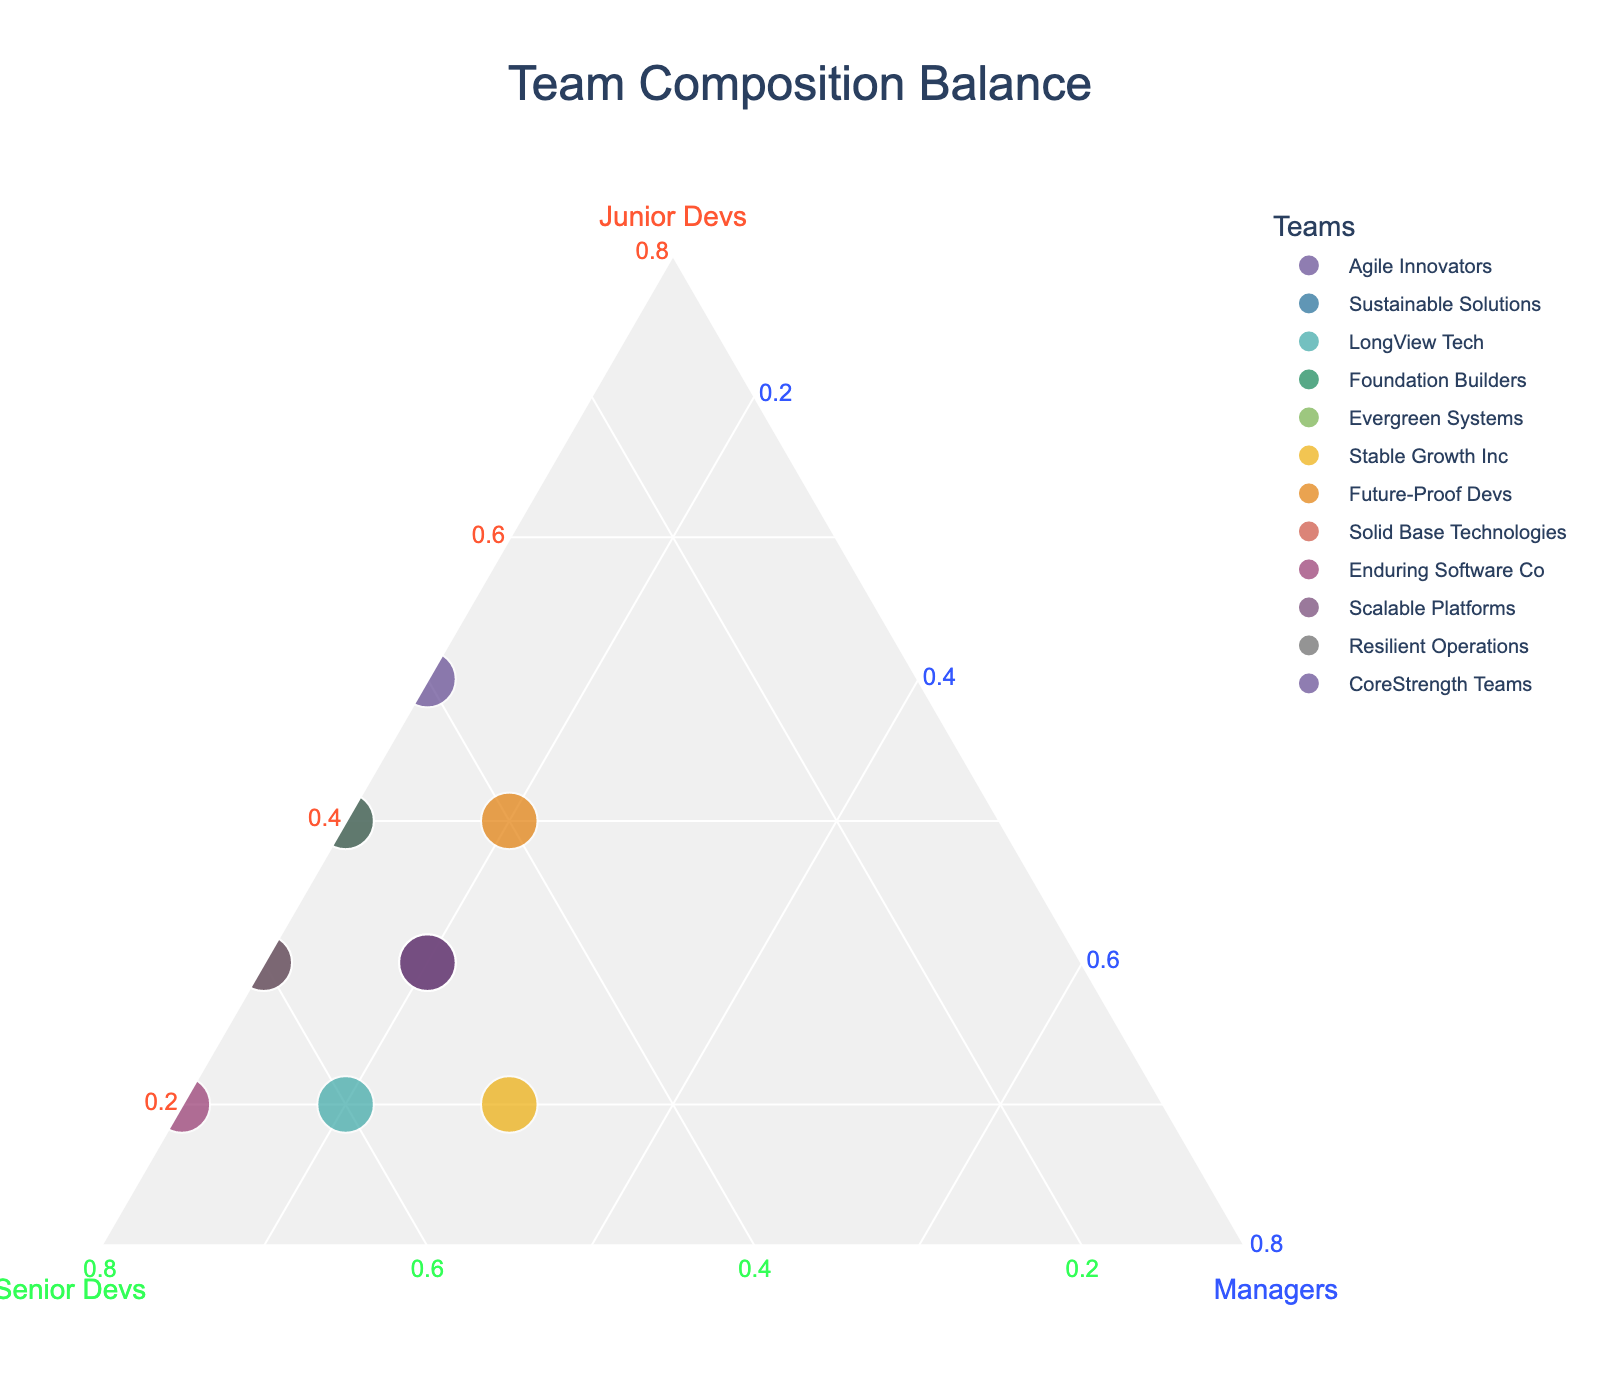What is the title of the figure? The title is usually prominently displayed at the top of the plot. In this case, it is mentioned in the figure generation script.
Answer: Team Composition Balance What team has the highest proportion of Senior Developers? To find this, look at the point closest to the Senior Devs axis (Green line). "Enduring Software Co" is closest.
Answer: Enduring Software Co Which team has an equal proportion of Junior Developers and Senior Developers? Look for a point on the plot where the coordinates for Junior and Senior are equal. "Agile Innovators" is closest to this equality.
Answer: Agile Innovators What is the proportion of Managers in the "Stable Growth Inc" team? Hover over or find "Stable Growth Inc" on the plot and check the value along the Managers axis (Blue line).
Answer: 30% Which team has a composition of 40% Junior Developers and 40% Senior Developers? Look for a point where the Junior and Senior Developer axes both indicate 40%. This is "Future-Proof Devs".
Answer: Future-Proof Devs Compare the proportion of Junior Developers between "Agile Innovators" and "Foundation Builders". Check the value along the Junior Developers axis (Red line) for both teams and compare. Both have the same value, 40%.
Answer: Both have 40% Which teams have the least proportion of Managers? Identify points near the bottom (Managers axis). "Agile Innovators", "Foundation Builders", "Evergreen Systems", "Enduring Software Co", "Scalable Platforms", and "Resilient Operations" each have 10%.
Answer: Agile Innovators, Foundation Builders, Evergreen Systems, Enduring Software Co, Scalable Platforms, Resilient Operations What is the predominant development role in "LongView Tech"? Check the positioning where the value closest is for the Senior Devs axis (Green line). The highest proportion is for Senior Developers.
Answer: Senior Developers Which team has the most balanced composition across all three roles? Balance means nearly equal proportions. "Stable Growth Inc" has closest proportions: 20% Junior, 50% Senior, and 30% Managers.
Answer: Stable Growth Inc 